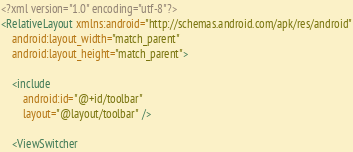<code> <loc_0><loc_0><loc_500><loc_500><_XML_><?xml version="1.0" encoding="utf-8"?>
<RelativeLayout xmlns:android="http://schemas.android.com/apk/res/android"
    android:layout_width="match_parent"
    android:layout_height="match_parent">

    <include
        android:id="@+id/toolbar"
        layout="@layout/toolbar" />

    <ViewSwitcher</code> 